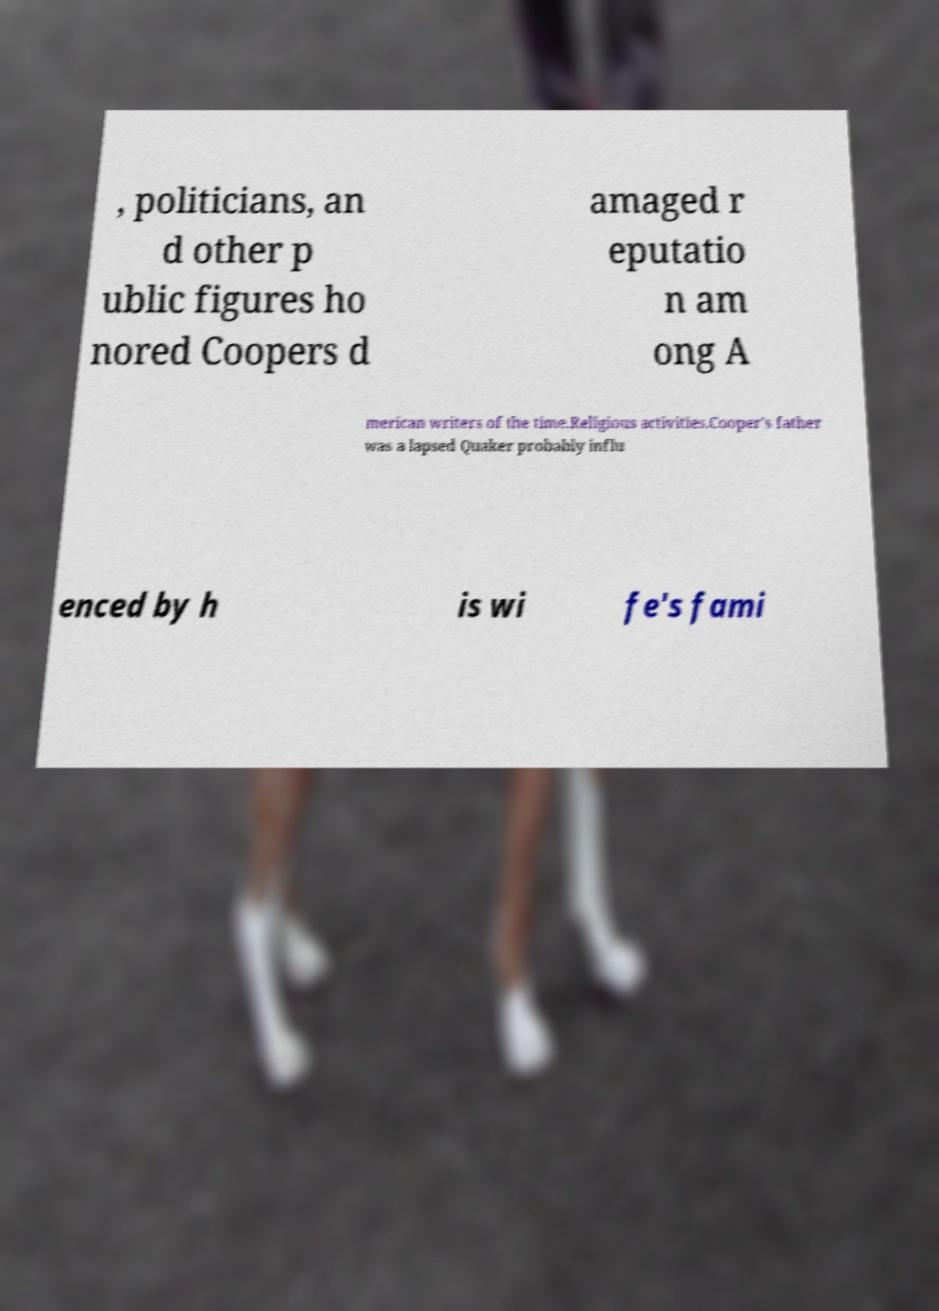Please identify and transcribe the text found in this image. , politicians, an d other p ublic figures ho nored Coopers d amaged r eputatio n am ong A merican writers of the time.Religious activities.Cooper's father was a lapsed Quaker probably influ enced by h is wi fe's fami 